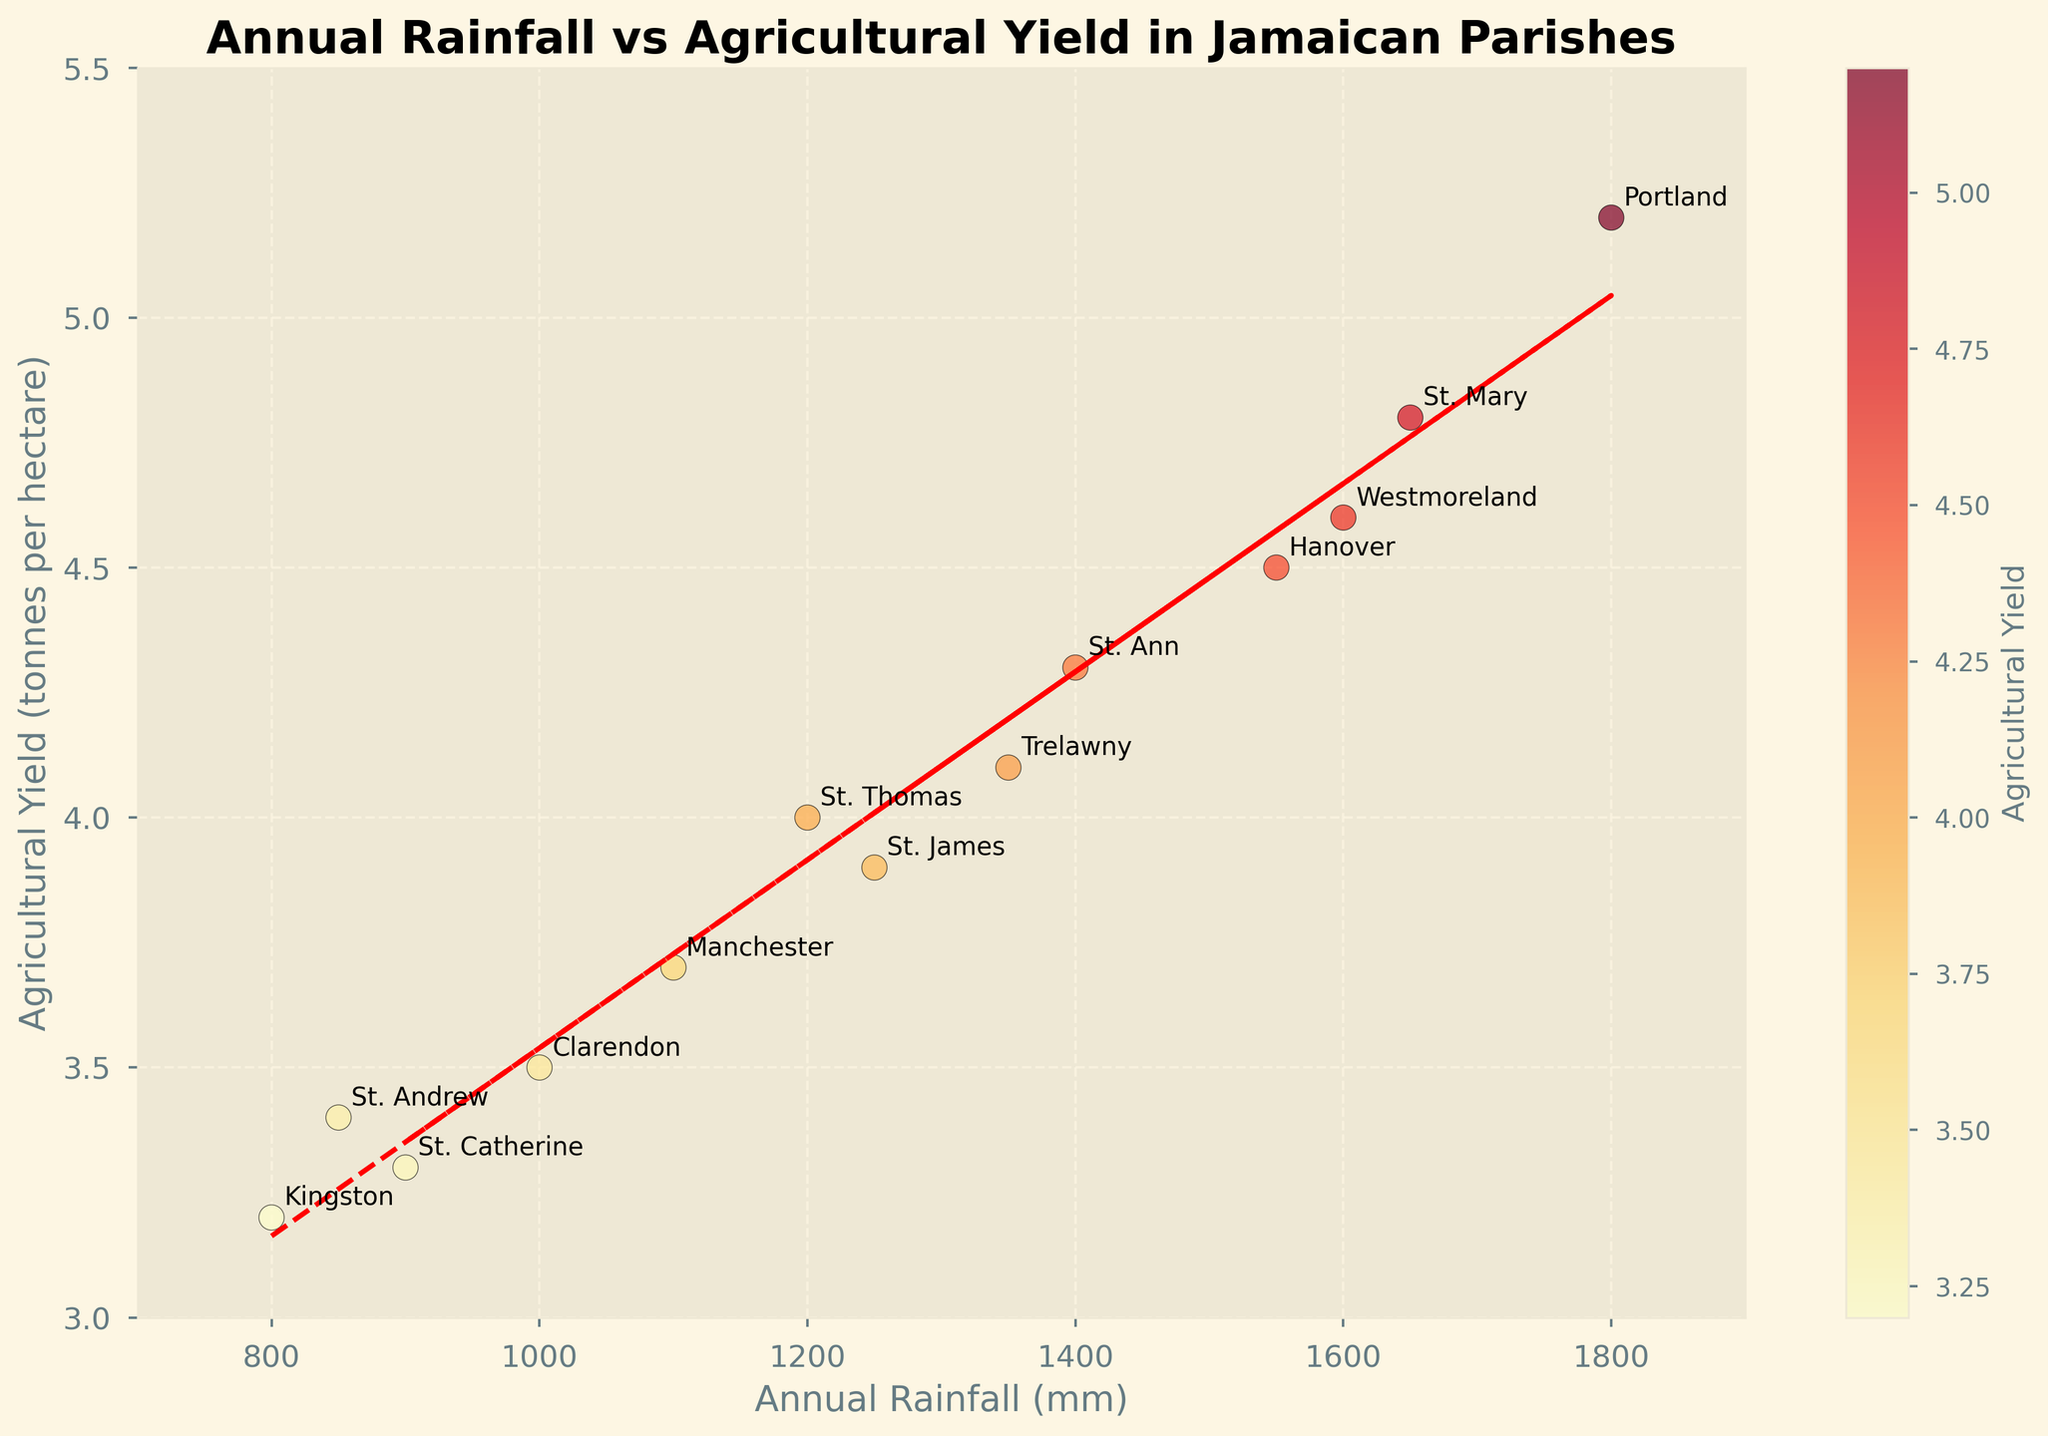what is the title of the plot? The title of a plot is typically located at the top center of the figure, summarizing what the data in the figure represents or compares. In this case, the title describes the relationship between annual rainfall and agricultural yield in Jamaican parishes.
Answer: Annual Rainfall vs Agricultural Yield in Jamaican Parishes What are the labels on the x and y axes? The labels on the x and y axes describe what each axis represents. The x-axis label indicates the quantity of annual rainfall in millimeters, while the y-axis label shows the agricultural yield in tonnes per hectare. These labels help viewers understand the data being plotted.
Answer: Annual Rainfall (mm) and Agricultural Yield (tonnes per hectare) How many data points are represented in the plot? To identify the number of data points, count the individual markers (dots) on the scatter plot. Each marker represents one data point corresponding to a pair of "Annual Rainfall" and "Agricultural Yield" values for a parish.
Answer: 13 Which parish has the highest agricultural yield? Look for the data point with the highest y-value on the scatter plot. The highest y-value corresponds to the highest agricultural yield. Identify the parish labeled at that data point.
Answer: Portland What is the approximate value of the trend line slope? The slope of the trend line can be inferred from the red dashed line in the plot. The slope will indicate the rate of change in the agricultural yield with respect to the annual rainfall. A steeper slope implies a stronger relationship.
Answer: Positive slope Which parish has the lowest annual rainfall, and what is its agricultural yield? Find the data point with the lowest x-value, which represents the minimum annual rainfall. The corresponding y-value at this data point will be the agricultural yield. Identify the parish labeled at that point.
Answer: Kingston, 3.2 tonnes per hectare Is there a positive correlation between annual rainfall and agricultural yield? To determine the correlation, observe the trend line direction. If the trend line slopes upward from left to right, there is a positive correlation, suggesting that higher annual rainfall is associated with higher agricultural yield.
Answer: Yes, there is a positive correlation Which parishes have an agricultural yield greater than 4 tonnes per hectare? Identify the data points where the y-value is greater than 4. Then, look at the labels next to those data points to determine the corresponding parishes.
Answer: St. Thomas, Portland, St. Mary, St. Ann, Hanover, Westmoreland What is the range of annual rainfall represented in the plot? The range of annual rainfall is found by identifying the minimum and maximum values on the x-axis. Calculate the difference between the highest and lowest x-values displayed on the plot.
Answer: From 800 mm to 1800 mm Do any parishes have similar annual rainfall but different agricultural yields? Look for clusters of data points that have similar x-values (annual rainfall) but different y-values (agricultural yield). Identify the parishes at those points to compare their yields.
Answer: St. Thomas and St. James 